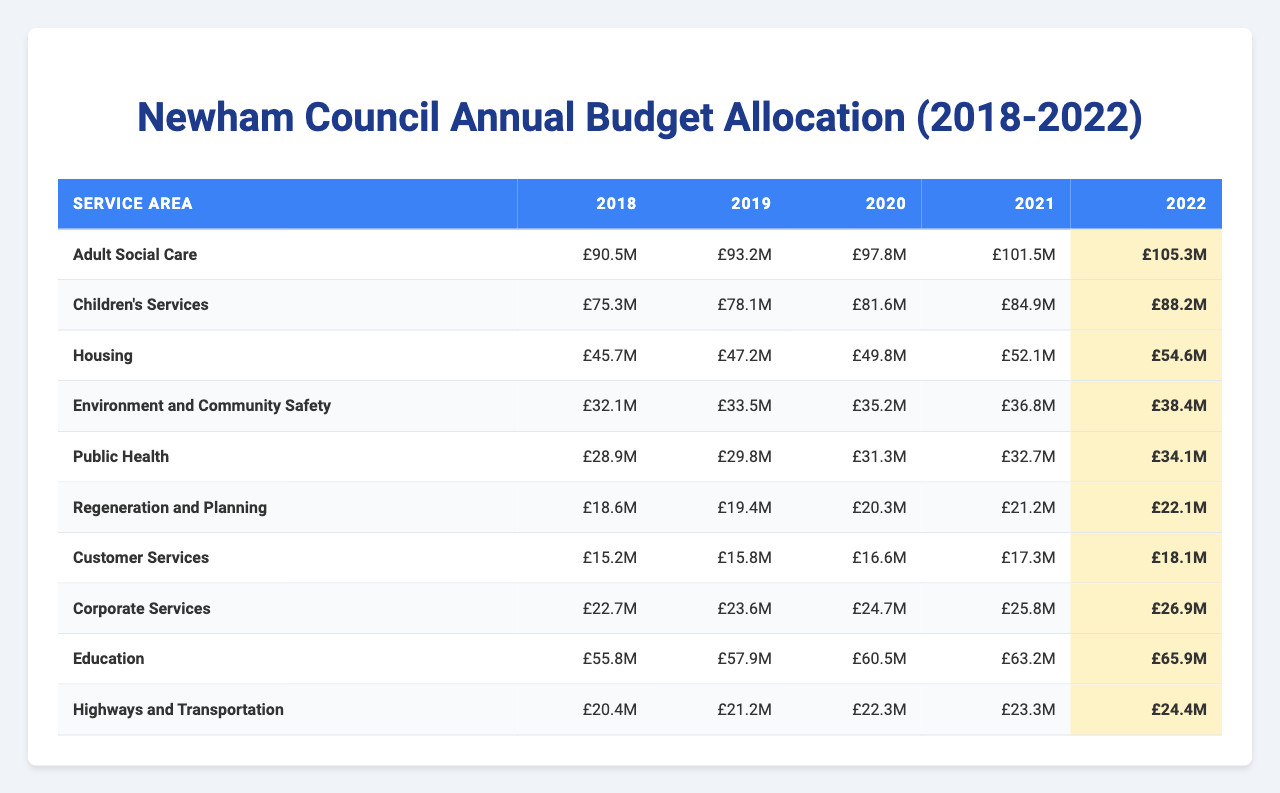what was the budget allocation for Adult Social Care in 2022? The table shows the budget for Adult Social Care in 2022, which is £105.3 million.
Answer: £105.3 million which service area had the highest budget allocation in 2021? To find the highest allocation in 2021, we look at the figures for each service area in that year. Adult Social Care has £101.5 million, Children's Services is £84.9 million, Housing is £52.1 million, and so on. Adult Social Care has the highest amount.
Answer: Adult Social Care what is the total budget allocation for Housing from 2018 to 2022? We sum the allocations for Housing from each year: £45.7 million + £47.2 million + £49.8 million + £52.1 million + £54.6 million = £249.4 million.
Answer: £249.4 million how much did Public Health's budget increase from 2018 to 2022? The budget for Public Health in 2018 was £28.9 million, and in 2022 it was £34.1 million. The increase is calculated as £34.1 million - £28.9 million = £5.2 million.
Answer: £5.2 million what is the average annual budget allocation for Corporate Services over the five years? The allocations for Corporate Services are £22.7 million, £23.6 million, £24.7 million, £25.8 million, and £26.9 million. We sum these values to get £123.7 million and divide by 5, resulting in an average of £24.74 million.
Answer: £24.74 million is the budget for Environment and Community Safety consistently increasing each year? To determine if the budget is consistently increasing, we check the figures: £32.1 million in 2018, £33.5 million in 2019, £35.2 million in 2020, £36.8 million in 2021, and £38.4 million in 2022. All values show an increase.
Answer: Yes which service area saw the smallest increase in budget from 2018 to 2022? We analyze the budget increases: Adult Social Care: £105.3M - £90.5M = £14.8M, Children's Services: £88.2M - £75.3M = £12.9M, Housing: £54.6M - £45.7M = £8.9M, and so on. The smallest increase is in Housing.
Answer: Housing what was the difference in budget allocation between Education and Children's Services in 2020? The budgets for 2020 are: Education: £60.5 million, Children's Services: £81.6 million. The difference is calculated as £81.6 million - £60.5 million = £21.1 million.
Answer: £21.1 million how much more was allocated to Adult Social Care than Regeneration and Planning in 2019? The budget allocation for Adult Social Care in 2019 is £93.2 million, and for Regeneration and Planning, it is £19.4 million. The difference is £93.2 million - £19.4 million = £73.8 million.
Answer: £73.8 million what was the median budget allocation for Highways and Transportation over the five years? The allocations for Highways and Transportation are £20.4 million, £21.2 million, £22.3 million, £23.3 million, and £24.4 million. Arranging these values gives us: 20.4, 21.2, 22.3, 23.3, 24.4. The median, being the middle value, is £22.3 million.
Answer: £22.3 million 